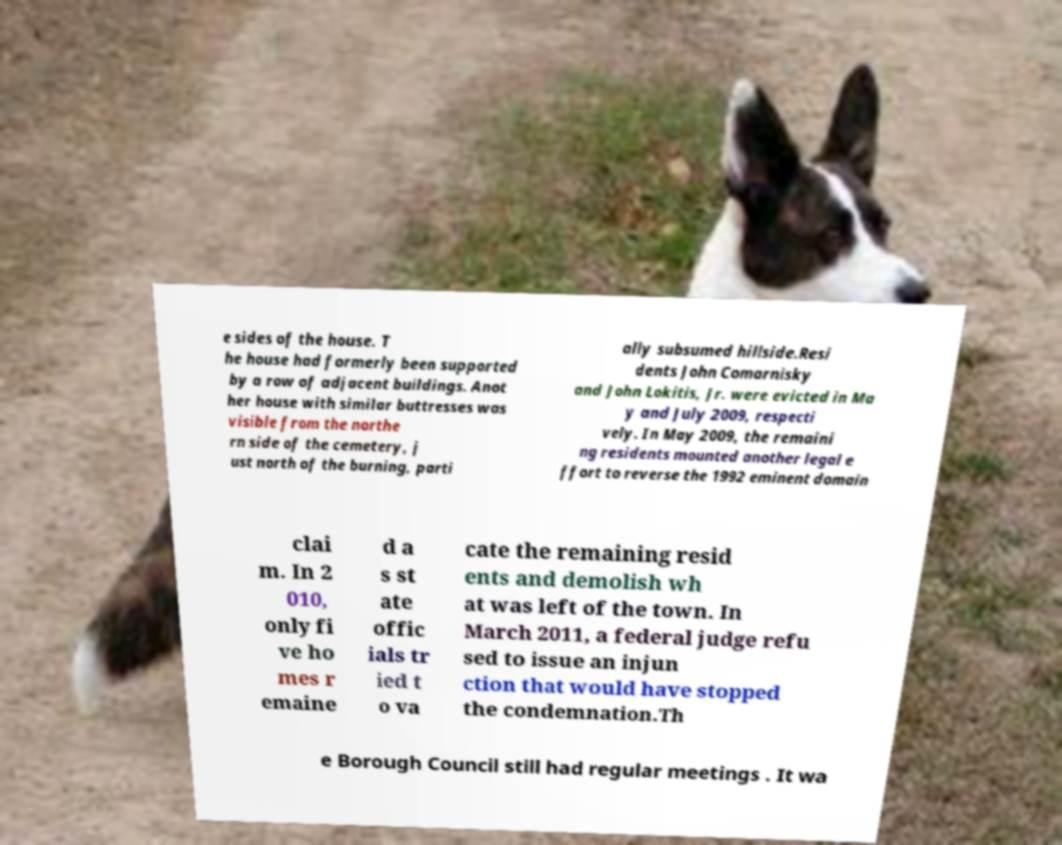What messages or text are displayed in this image? I need them in a readable, typed format. e sides of the house. T he house had formerly been supported by a row of adjacent buildings. Anot her house with similar buttresses was visible from the northe rn side of the cemetery, j ust north of the burning, parti ally subsumed hillside.Resi dents John Comarnisky and John Lokitis, Jr. were evicted in Ma y and July 2009, respecti vely. In May 2009, the remaini ng residents mounted another legal e ffort to reverse the 1992 eminent domain clai m. In 2 010, only fi ve ho mes r emaine d a s st ate offic ials tr ied t o va cate the remaining resid ents and demolish wh at was left of the town. In March 2011, a federal judge refu sed to issue an injun ction that would have stopped the condemnation.Th e Borough Council still had regular meetings . It wa 